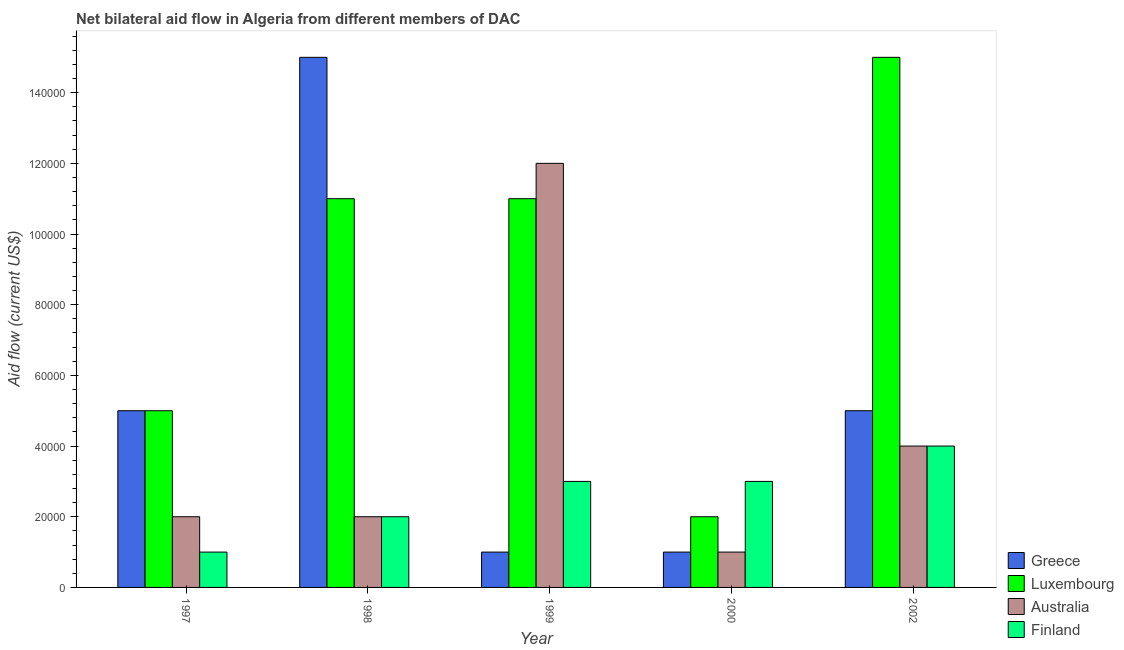Are the number of bars per tick equal to the number of legend labels?
Your answer should be compact. Yes. Are the number of bars on each tick of the X-axis equal?
Provide a succinct answer. Yes. How many bars are there on the 3rd tick from the left?
Offer a terse response. 4. How many bars are there on the 3rd tick from the right?
Ensure brevity in your answer.  4. What is the label of the 1st group of bars from the left?
Give a very brief answer. 1997. What is the amount of aid given by finland in 1997?
Give a very brief answer. 10000. Across all years, what is the maximum amount of aid given by greece?
Make the answer very short. 1.50e+05. Across all years, what is the minimum amount of aid given by finland?
Your answer should be compact. 10000. What is the total amount of aid given by finland in the graph?
Your answer should be compact. 1.30e+05. What is the difference between the amount of aid given by luxembourg in 1997 and the amount of aid given by australia in 2002?
Keep it short and to the point. -1.00e+05. What is the average amount of aid given by greece per year?
Your response must be concise. 5.40e+04. In the year 1997, what is the difference between the amount of aid given by finland and amount of aid given by australia?
Your answer should be very brief. 0. In how many years, is the amount of aid given by luxembourg greater than 152000 US$?
Offer a terse response. 0. Is the difference between the amount of aid given by luxembourg in 1997 and 1998 greater than the difference between the amount of aid given by finland in 1997 and 1998?
Offer a very short reply. No. What is the difference between the highest and the lowest amount of aid given by greece?
Make the answer very short. 1.40e+05. Is the sum of the amount of aid given by finland in 1997 and 2000 greater than the maximum amount of aid given by greece across all years?
Your response must be concise. No. What does the 3rd bar from the left in 1998 represents?
Your answer should be compact. Australia. What does the 3rd bar from the right in 1998 represents?
Provide a short and direct response. Luxembourg. Is it the case that in every year, the sum of the amount of aid given by greece and amount of aid given by luxembourg is greater than the amount of aid given by australia?
Provide a succinct answer. No. How many bars are there?
Keep it short and to the point. 20. Are all the bars in the graph horizontal?
Provide a short and direct response. No. How many years are there in the graph?
Keep it short and to the point. 5. How many legend labels are there?
Give a very brief answer. 4. How are the legend labels stacked?
Ensure brevity in your answer.  Vertical. What is the title of the graph?
Provide a short and direct response. Net bilateral aid flow in Algeria from different members of DAC. What is the Aid flow (current US$) in Greece in 1997?
Your answer should be very brief. 5.00e+04. What is the Aid flow (current US$) in Luxembourg in 1997?
Keep it short and to the point. 5.00e+04. What is the Aid flow (current US$) of Finland in 1997?
Make the answer very short. 10000. What is the Aid flow (current US$) of Luxembourg in 1998?
Provide a succinct answer. 1.10e+05. What is the Aid flow (current US$) of Finland in 1998?
Offer a terse response. 2.00e+04. What is the Aid flow (current US$) in Greece in 1999?
Provide a succinct answer. 10000. What is the Aid flow (current US$) of Greece in 2000?
Give a very brief answer. 10000. What is the Aid flow (current US$) of Finland in 2002?
Give a very brief answer. 4.00e+04. Across all years, what is the maximum Aid flow (current US$) in Greece?
Make the answer very short. 1.50e+05. Across all years, what is the maximum Aid flow (current US$) of Luxembourg?
Make the answer very short. 1.50e+05. Across all years, what is the maximum Aid flow (current US$) in Australia?
Provide a succinct answer. 1.20e+05. Across all years, what is the minimum Aid flow (current US$) of Luxembourg?
Make the answer very short. 2.00e+04. Across all years, what is the minimum Aid flow (current US$) of Australia?
Provide a succinct answer. 10000. Across all years, what is the minimum Aid flow (current US$) of Finland?
Offer a terse response. 10000. What is the total Aid flow (current US$) of Luxembourg in the graph?
Ensure brevity in your answer.  4.40e+05. What is the total Aid flow (current US$) in Finland in the graph?
Offer a very short reply. 1.30e+05. What is the difference between the Aid flow (current US$) in Greece in 1997 and that in 1999?
Provide a succinct answer. 4.00e+04. What is the difference between the Aid flow (current US$) of Australia in 1997 and that in 1999?
Ensure brevity in your answer.  -1.00e+05. What is the difference between the Aid flow (current US$) in Australia in 1997 and that in 2000?
Keep it short and to the point. 10000. What is the difference between the Aid flow (current US$) of Luxembourg in 1997 and that in 2002?
Provide a succinct answer. -1.00e+05. What is the difference between the Aid flow (current US$) in Australia in 1997 and that in 2002?
Offer a very short reply. -2.00e+04. What is the difference between the Aid flow (current US$) of Finland in 1997 and that in 2002?
Your response must be concise. -3.00e+04. What is the difference between the Aid flow (current US$) in Luxembourg in 1998 and that in 1999?
Ensure brevity in your answer.  0. What is the difference between the Aid flow (current US$) of Australia in 1998 and that in 1999?
Give a very brief answer. -1.00e+05. What is the difference between the Aid flow (current US$) of Finland in 1998 and that in 1999?
Your answer should be very brief. -10000. What is the difference between the Aid flow (current US$) of Australia in 1998 and that in 2000?
Provide a short and direct response. 10000. What is the difference between the Aid flow (current US$) of Finland in 1998 and that in 2000?
Your response must be concise. -10000. What is the difference between the Aid flow (current US$) of Greece in 1998 and that in 2002?
Provide a succinct answer. 1.00e+05. What is the difference between the Aid flow (current US$) in Luxembourg in 1998 and that in 2002?
Provide a succinct answer. -4.00e+04. What is the difference between the Aid flow (current US$) of Greece in 1999 and that in 2000?
Provide a succinct answer. 0. What is the difference between the Aid flow (current US$) in Australia in 1999 and that in 2000?
Make the answer very short. 1.10e+05. What is the difference between the Aid flow (current US$) of Greece in 1999 and that in 2002?
Make the answer very short. -4.00e+04. What is the difference between the Aid flow (current US$) of Greece in 2000 and that in 2002?
Offer a terse response. -4.00e+04. What is the difference between the Aid flow (current US$) in Finland in 2000 and that in 2002?
Make the answer very short. -10000. What is the difference between the Aid flow (current US$) in Luxembourg in 1997 and the Aid flow (current US$) in Australia in 1998?
Offer a terse response. 3.00e+04. What is the difference between the Aid flow (current US$) in Luxembourg in 1997 and the Aid flow (current US$) in Finland in 1998?
Offer a very short reply. 3.00e+04. What is the difference between the Aid flow (current US$) in Greece in 1997 and the Aid flow (current US$) in Luxembourg in 1999?
Keep it short and to the point. -6.00e+04. What is the difference between the Aid flow (current US$) of Greece in 1997 and the Aid flow (current US$) of Finland in 1999?
Offer a terse response. 2.00e+04. What is the difference between the Aid flow (current US$) in Australia in 1997 and the Aid flow (current US$) in Finland in 1999?
Ensure brevity in your answer.  -10000. What is the difference between the Aid flow (current US$) in Greece in 1997 and the Aid flow (current US$) in Luxembourg in 2000?
Give a very brief answer. 3.00e+04. What is the difference between the Aid flow (current US$) in Greece in 1997 and the Aid flow (current US$) in Australia in 2000?
Make the answer very short. 4.00e+04. What is the difference between the Aid flow (current US$) in Greece in 1997 and the Aid flow (current US$) in Australia in 2002?
Your response must be concise. 10000. What is the difference between the Aid flow (current US$) of Greece in 1997 and the Aid flow (current US$) of Finland in 2002?
Provide a short and direct response. 10000. What is the difference between the Aid flow (current US$) of Greece in 1998 and the Aid flow (current US$) of Australia in 1999?
Give a very brief answer. 3.00e+04. What is the difference between the Aid flow (current US$) in Luxembourg in 1998 and the Aid flow (current US$) in Australia in 1999?
Make the answer very short. -10000. What is the difference between the Aid flow (current US$) of Luxembourg in 1998 and the Aid flow (current US$) of Finland in 1999?
Ensure brevity in your answer.  8.00e+04. What is the difference between the Aid flow (current US$) of Australia in 1998 and the Aid flow (current US$) of Finland in 1999?
Your answer should be very brief. -10000. What is the difference between the Aid flow (current US$) in Greece in 1998 and the Aid flow (current US$) in Luxembourg in 2000?
Your answer should be compact. 1.30e+05. What is the difference between the Aid flow (current US$) of Greece in 1998 and the Aid flow (current US$) of Australia in 2000?
Provide a short and direct response. 1.40e+05. What is the difference between the Aid flow (current US$) of Greece in 1998 and the Aid flow (current US$) of Finland in 2000?
Keep it short and to the point. 1.20e+05. What is the difference between the Aid flow (current US$) of Luxembourg in 1998 and the Aid flow (current US$) of Australia in 2000?
Provide a short and direct response. 1.00e+05. What is the difference between the Aid flow (current US$) of Luxembourg in 1998 and the Aid flow (current US$) of Finland in 2000?
Your response must be concise. 8.00e+04. What is the difference between the Aid flow (current US$) in Greece in 1998 and the Aid flow (current US$) in Australia in 2002?
Offer a very short reply. 1.10e+05. What is the difference between the Aid flow (current US$) of Luxembourg in 1998 and the Aid flow (current US$) of Australia in 2002?
Give a very brief answer. 7.00e+04. What is the difference between the Aid flow (current US$) of Luxembourg in 1998 and the Aid flow (current US$) of Finland in 2002?
Offer a terse response. 7.00e+04. What is the difference between the Aid flow (current US$) of Greece in 1999 and the Aid flow (current US$) of Luxembourg in 2000?
Offer a very short reply. -10000. What is the difference between the Aid flow (current US$) in Greece in 1999 and the Aid flow (current US$) in Australia in 2000?
Keep it short and to the point. 0. What is the difference between the Aid flow (current US$) of Luxembourg in 1999 and the Aid flow (current US$) of Australia in 2000?
Ensure brevity in your answer.  1.00e+05. What is the difference between the Aid flow (current US$) of Luxembourg in 1999 and the Aid flow (current US$) of Finland in 2000?
Your answer should be very brief. 8.00e+04. What is the difference between the Aid flow (current US$) of Australia in 1999 and the Aid flow (current US$) of Finland in 2000?
Offer a terse response. 9.00e+04. What is the difference between the Aid flow (current US$) of Greece in 1999 and the Aid flow (current US$) of Luxembourg in 2002?
Provide a short and direct response. -1.40e+05. What is the difference between the Aid flow (current US$) in Greece in 1999 and the Aid flow (current US$) in Finland in 2002?
Offer a very short reply. -3.00e+04. What is the difference between the Aid flow (current US$) in Luxembourg in 1999 and the Aid flow (current US$) in Australia in 2002?
Ensure brevity in your answer.  7.00e+04. What is the difference between the Aid flow (current US$) in Luxembourg in 1999 and the Aid flow (current US$) in Finland in 2002?
Give a very brief answer. 7.00e+04. What is the difference between the Aid flow (current US$) of Luxembourg in 2000 and the Aid flow (current US$) of Australia in 2002?
Offer a terse response. -2.00e+04. What is the difference between the Aid flow (current US$) of Luxembourg in 2000 and the Aid flow (current US$) of Finland in 2002?
Your response must be concise. -2.00e+04. What is the average Aid flow (current US$) in Greece per year?
Offer a very short reply. 5.40e+04. What is the average Aid flow (current US$) in Luxembourg per year?
Provide a short and direct response. 8.80e+04. What is the average Aid flow (current US$) in Australia per year?
Your answer should be compact. 4.20e+04. What is the average Aid flow (current US$) in Finland per year?
Offer a terse response. 2.60e+04. In the year 1997, what is the difference between the Aid flow (current US$) of Greece and Aid flow (current US$) of Luxembourg?
Give a very brief answer. 0. In the year 1997, what is the difference between the Aid flow (current US$) in Greece and Aid flow (current US$) in Australia?
Make the answer very short. 3.00e+04. In the year 1997, what is the difference between the Aid flow (current US$) of Greece and Aid flow (current US$) of Finland?
Offer a very short reply. 4.00e+04. In the year 1997, what is the difference between the Aid flow (current US$) in Luxembourg and Aid flow (current US$) in Australia?
Provide a short and direct response. 3.00e+04. In the year 1997, what is the difference between the Aid flow (current US$) in Australia and Aid flow (current US$) in Finland?
Provide a succinct answer. 10000. In the year 1998, what is the difference between the Aid flow (current US$) in Greece and Aid flow (current US$) in Luxembourg?
Keep it short and to the point. 4.00e+04. In the year 1998, what is the difference between the Aid flow (current US$) of Greece and Aid flow (current US$) of Australia?
Your answer should be very brief. 1.30e+05. In the year 1998, what is the difference between the Aid flow (current US$) in Greece and Aid flow (current US$) in Finland?
Make the answer very short. 1.30e+05. In the year 1998, what is the difference between the Aid flow (current US$) in Luxembourg and Aid flow (current US$) in Australia?
Give a very brief answer. 9.00e+04. In the year 1998, what is the difference between the Aid flow (current US$) in Luxembourg and Aid flow (current US$) in Finland?
Your response must be concise. 9.00e+04. In the year 1999, what is the difference between the Aid flow (current US$) in Luxembourg and Aid flow (current US$) in Australia?
Your answer should be compact. -10000. In the year 1999, what is the difference between the Aid flow (current US$) of Australia and Aid flow (current US$) of Finland?
Keep it short and to the point. 9.00e+04. In the year 2000, what is the difference between the Aid flow (current US$) of Greece and Aid flow (current US$) of Luxembourg?
Offer a very short reply. -10000. In the year 2000, what is the difference between the Aid flow (current US$) in Greece and Aid flow (current US$) in Finland?
Ensure brevity in your answer.  -2.00e+04. In the year 2000, what is the difference between the Aid flow (current US$) in Luxembourg and Aid flow (current US$) in Australia?
Offer a very short reply. 10000. In the year 2000, what is the difference between the Aid flow (current US$) in Luxembourg and Aid flow (current US$) in Finland?
Offer a very short reply. -10000. In the year 2000, what is the difference between the Aid flow (current US$) in Australia and Aid flow (current US$) in Finland?
Your answer should be very brief. -2.00e+04. In the year 2002, what is the difference between the Aid flow (current US$) of Greece and Aid flow (current US$) of Luxembourg?
Keep it short and to the point. -1.00e+05. In the year 2002, what is the difference between the Aid flow (current US$) in Greece and Aid flow (current US$) in Australia?
Keep it short and to the point. 10000. What is the ratio of the Aid flow (current US$) of Luxembourg in 1997 to that in 1998?
Give a very brief answer. 0.45. What is the ratio of the Aid flow (current US$) of Australia in 1997 to that in 1998?
Your response must be concise. 1. What is the ratio of the Aid flow (current US$) of Greece in 1997 to that in 1999?
Keep it short and to the point. 5. What is the ratio of the Aid flow (current US$) in Luxembourg in 1997 to that in 1999?
Give a very brief answer. 0.45. What is the ratio of the Aid flow (current US$) in Australia in 1997 to that in 1999?
Make the answer very short. 0.17. What is the ratio of the Aid flow (current US$) in Finland in 1997 to that in 1999?
Give a very brief answer. 0.33. What is the ratio of the Aid flow (current US$) of Luxembourg in 1997 to that in 2000?
Your response must be concise. 2.5. What is the ratio of the Aid flow (current US$) of Australia in 1997 to that in 2000?
Give a very brief answer. 2. What is the ratio of the Aid flow (current US$) in Luxembourg in 1997 to that in 2002?
Provide a short and direct response. 0.33. What is the ratio of the Aid flow (current US$) in Australia in 1997 to that in 2002?
Keep it short and to the point. 0.5. What is the ratio of the Aid flow (current US$) in Finland in 1997 to that in 2002?
Keep it short and to the point. 0.25. What is the ratio of the Aid flow (current US$) of Luxembourg in 1998 to that in 1999?
Give a very brief answer. 1. What is the ratio of the Aid flow (current US$) in Australia in 1998 to that in 1999?
Offer a very short reply. 0.17. What is the ratio of the Aid flow (current US$) of Luxembourg in 1998 to that in 2000?
Make the answer very short. 5.5. What is the ratio of the Aid flow (current US$) in Australia in 1998 to that in 2000?
Your response must be concise. 2. What is the ratio of the Aid flow (current US$) of Finland in 1998 to that in 2000?
Offer a very short reply. 0.67. What is the ratio of the Aid flow (current US$) of Luxembourg in 1998 to that in 2002?
Offer a very short reply. 0.73. What is the ratio of the Aid flow (current US$) of Australia in 1998 to that in 2002?
Offer a terse response. 0.5. What is the ratio of the Aid flow (current US$) in Finland in 1998 to that in 2002?
Your answer should be very brief. 0.5. What is the ratio of the Aid flow (current US$) in Australia in 1999 to that in 2000?
Your response must be concise. 12. What is the ratio of the Aid flow (current US$) in Finland in 1999 to that in 2000?
Provide a succinct answer. 1. What is the ratio of the Aid flow (current US$) in Greece in 1999 to that in 2002?
Your answer should be very brief. 0.2. What is the ratio of the Aid flow (current US$) of Luxembourg in 1999 to that in 2002?
Give a very brief answer. 0.73. What is the ratio of the Aid flow (current US$) of Luxembourg in 2000 to that in 2002?
Offer a very short reply. 0.13. What is the ratio of the Aid flow (current US$) of Australia in 2000 to that in 2002?
Give a very brief answer. 0.25. What is the difference between the highest and the second highest Aid flow (current US$) in Australia?
Provide a short and direct response. 8.00e+04. What is the difference between the highest and the lowest Aid flow (current US$) in Greece?
Make the answer very short. 1.40e+05. What is the difference between the highest and the lowest Aid flow (current US$) of Luxembourg?
Ensure brevity in your answer.  1.30e+05. What is the difference between the highest and the lowest Aid flow (current US$) of Finland?
Your answer should be compact. 3.00e+04. 